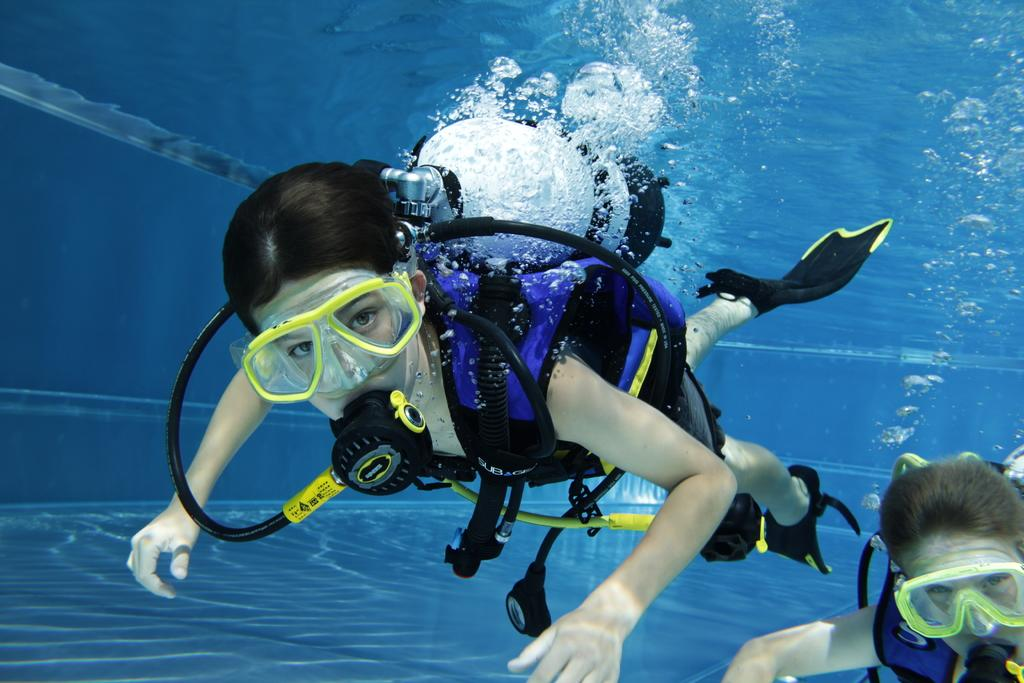How many people are in the image? There are two persons in the image. What are the persons wearing in the image? The persons are wearing oxygen cylinders in the image. Where are the persons located in the image? The persons are inside the water in the image. What type of whistle can be heard in the image? There is no whistle present in the image, and therefore no sound can be heard. 